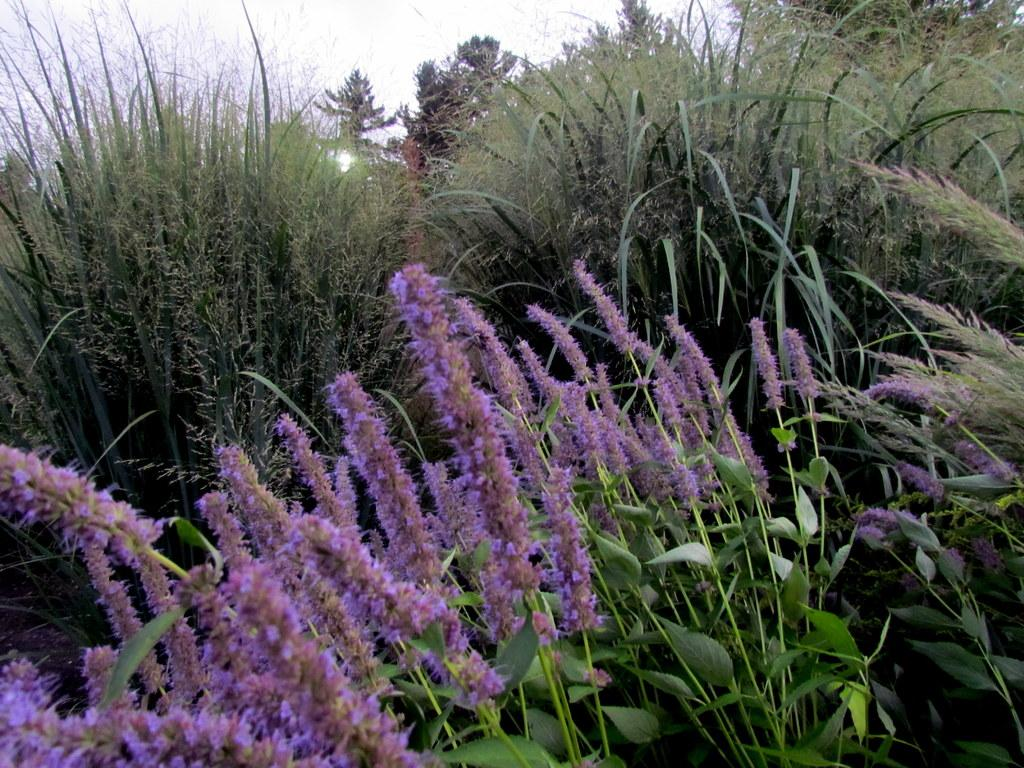What is the main subject of the image? The main subject of the image is flower plants. Where are the flower plants located in the image? The flower plants are in the center of the image. What can be seen in the background of the image? There is sky visible in the background of the image. What type of hat is the flower wearing in the image? There are no hats or living beings in the image, as it features flower plants. 